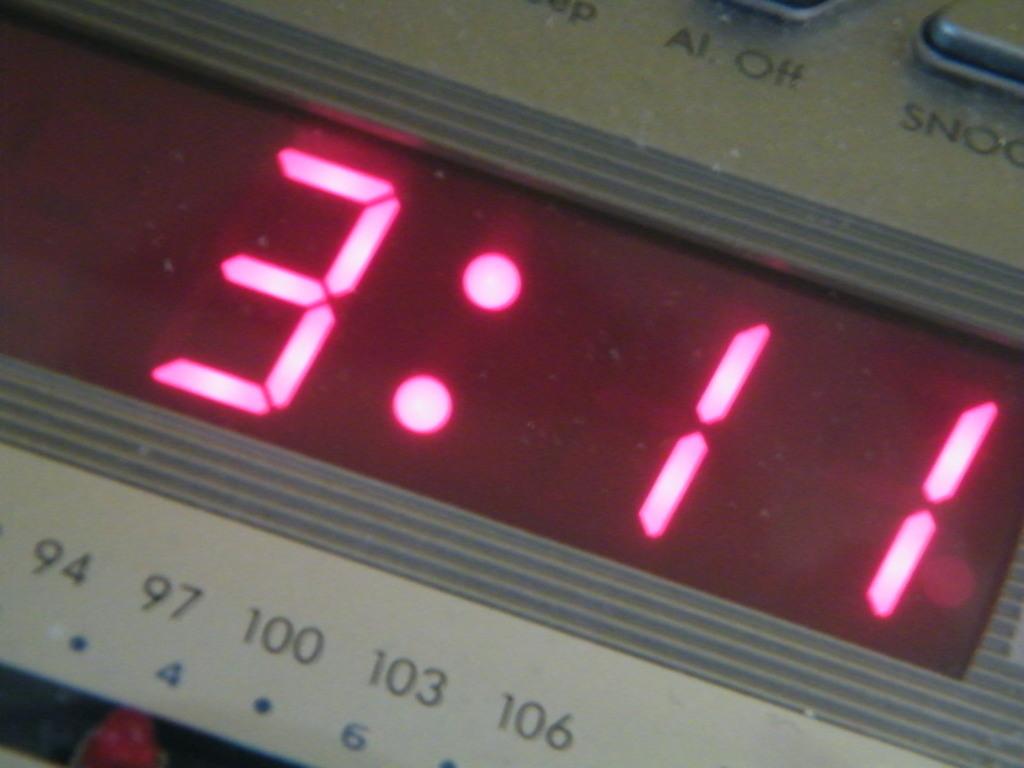What time is it?
Give a very brief answer. 3:11. Is there a snooze button on this clock radio?
Keep it short and to the point. Yes. 